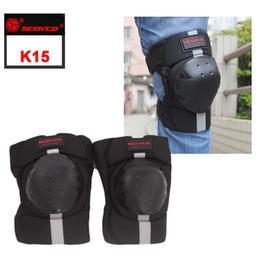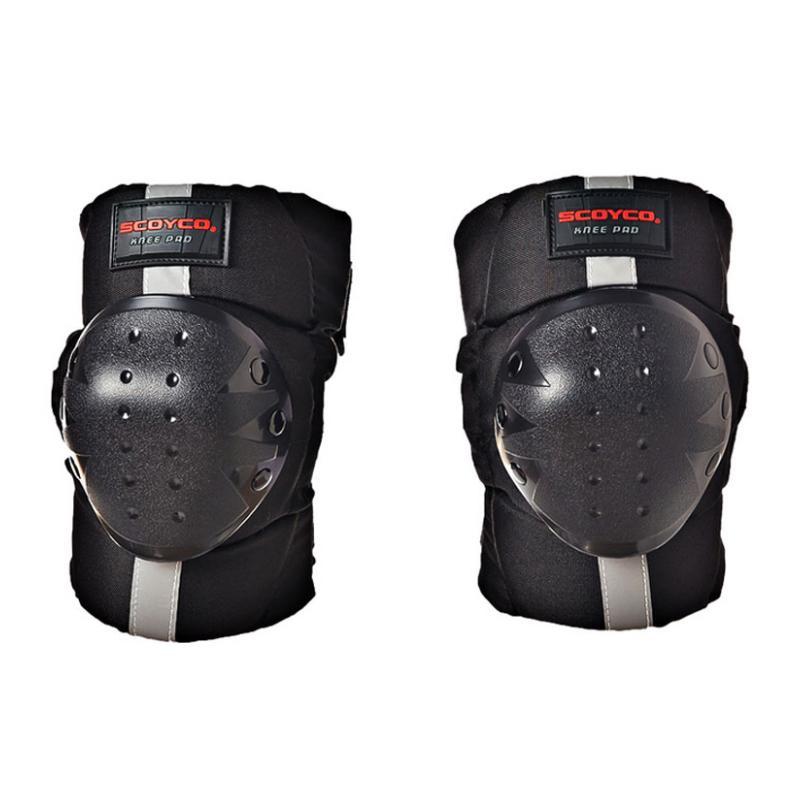The first image is the image on the left, the second image is the image on the right. Evaluate the accuracy of this statement regarding the images: "One image shows someone wearing at least one of the knee pads.". Is it true? Answer yes or no. Yes. The first image is the image on the left, the second image is the image on the right. For the images shown, is this caption "At least one of the images has a human model wearing the item." true? Answer yes or no. Yes. 